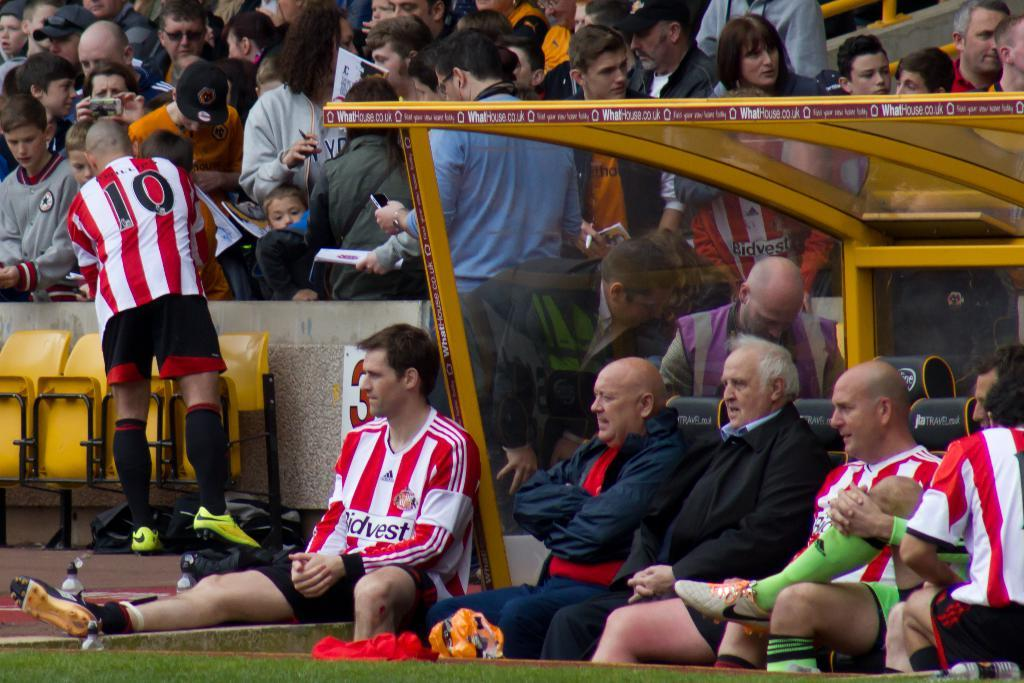What is happening at the bottom of the image? There are many persons sitting on chairs at the bottom of the image. What can be seen in the background of the image? In the background, there are chairs visible, and there is a crowd. What type of floor can be seen in the image? There is no specific mention of a floor in the image, as the focus is on the persons sitting on chairs and the crowd in the background. How does the crowd start moving in the image? The image does not depict the crowd moving or starting to move, so it is not possible to answer that question. 